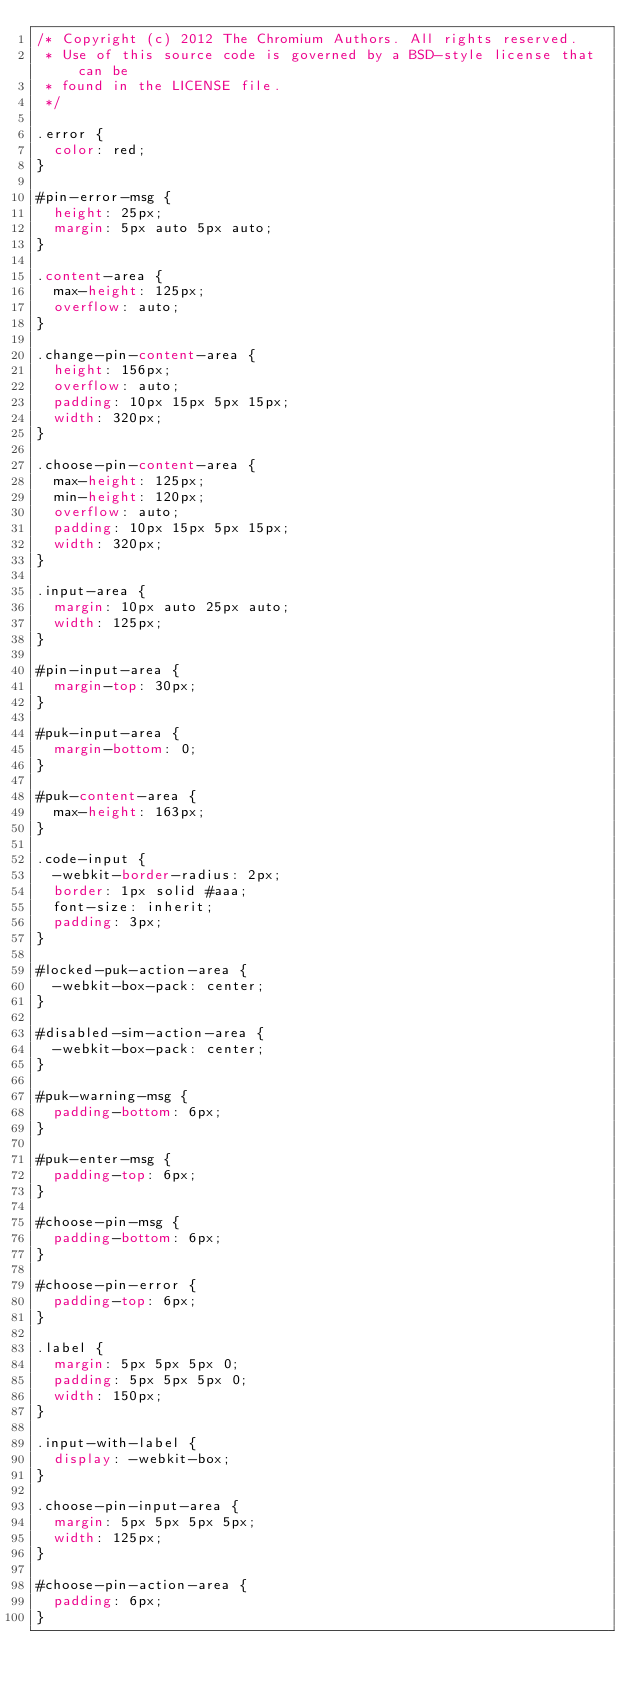<code> <loc_0><loc_0><loc_500><loc_500><_CSS_>/* Copyright (c) 2012 The Chromium Authors. All rights reserved.
 * Use of this source code is governed by a BSD-style license that can be
 * found in the LICENSE file.
 */

.error {
  color: red;
}

#pin-error-msg {
  height: 25px;
  margin: 5px auto 5px auto;
}

.content-area {
  max-height: 125px;
  overflow: auto;
}

.change-pin-content-area {
  height: 156px;
  overflow: auto;
  padding: 10px 15px 5px 15px;
  width: 320px;
}

.choose-pin-content-area {
  max-height: 125px;
  min-height: 120px;
  overflow: auto;
  padding: 10px 15px 5px 15px;
  width: 320px;
}

.input-area {
  margin: 10px auto 25px auto;
  width: 125px;
}

#pin-input-area {
  margin-top: 30px;
}

#puk-input-area {
  margin-bottom: 0;
}

#puk-content-area {
  max-height: 163px;
}

.code-input {
  -webkit-border-radius: 2px;
  border: 1px solid #aaa;
  font-size: inherit;
  padding: 3px;
}

#locked-puk-action-area {
  -webkit-box-pack: center;
}

#disabled-sim-action-area {
  -webkit-box-pack: center;
}

#puk-warning-msg {
  padding-bottom: 6px;
}

#puk-enter-msg {
  padding-top: 6px;
}

#choose-pin-msg {
  padding-bottom: 6px;
}

#choose-pin-error {
  padding-top: 6px;
}

.label {
  margin: 5px 5px 5px 0;
  padding: 5px 5px 5px 0;
  width: 150px;
}

.input-with-label {
  display: -webkit-box;
}

.choose-pin-input-area {
  margin: 5px 5px 5px 5px;
  width: 125px; 
}

#choose-pin-action-area {
  padding: 6px;
}
</code> 